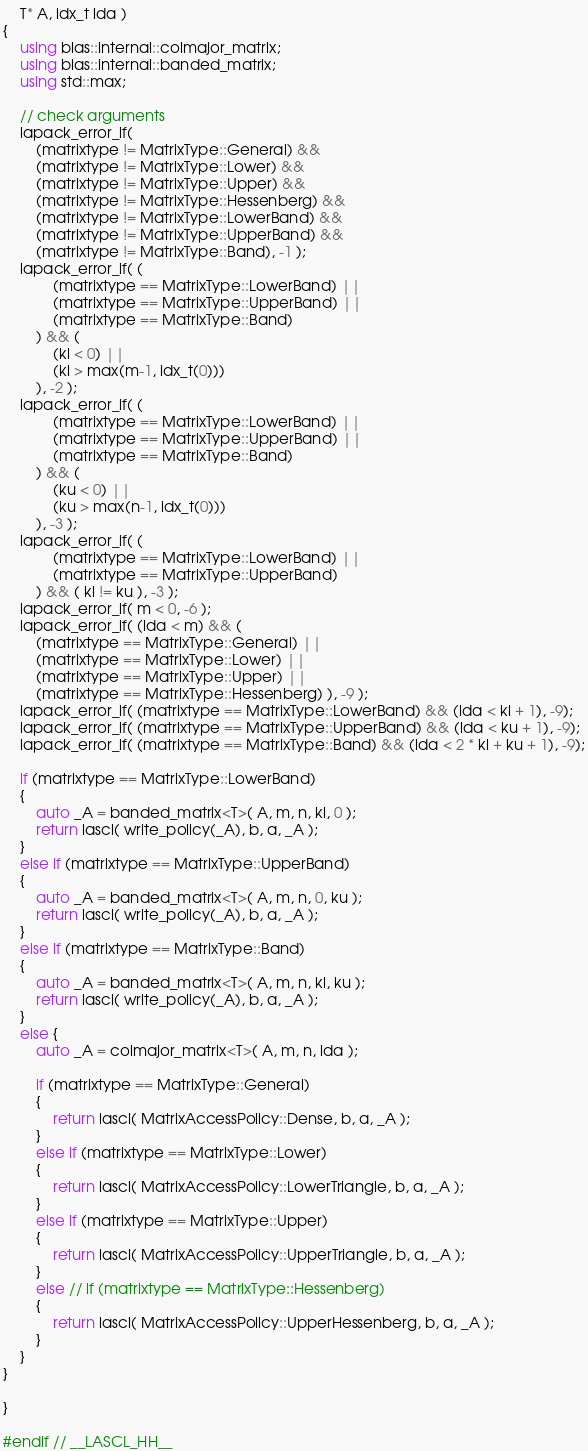<code> <loc_0><loc_0><loc_500><loc_500><_C++_>    T* A, idx_t lda )
{
    using blas::internal::colmajor_matrix;
    using blas::internal::banded_matrix;
    using std::max;
    
    // check arguments
    lapack_error_if(
        (matrixtype != MatrixType::General) && 
        (matrixtype != MatrixType::Lower) && 
        (matrixtype != MatrixType::Upper) && 
        (matrixtype != MatrixType::Hessenberg) && 
        (matrixtype != MatrixType::LowerBand) && 
        (matrixtype != MatrixType::UpperBand) && 
        (matrixtype != MatrixType::Band), -1 );
    lapack_error_if( (
            (matrixtype == MatrixType::LowerBand) ||
            (matrixtype == MatrixType::UpperBand) || 
            (matrixtype == MatrixType::Band)
        ) && (
            (kl < 0) ||
            (kl > max(m-1, idx_t(0)))
        ), -2 );
    lapack_error_if( (
            (matrixtype == MatrixType::LowerBand) ||
            (matrixtype == MatrixType::UpperBand) || 
            (matrixtype == MatrixType::Band)
        ) && (
            (ku < 0) ||
            (ku > max(n-1, idx_t(0)))
        ), -3 );
    lapack_error_if( (
            (matrixtype == MatrixType::LowerBand) ||
            (matrixtype == MatrixType::UpperBand)
        ) && ( kl != ku ), -3 );
    lapack_error_if( m < 0, -6 );
    lapack_error_if( (lda < m) && (
        (matrixtype == MatrixType::General) || 
        (matrixtype == MatrixType::Lower) ||
        (matrixtype == MatrixType::Upper) ||
        (matrixtype == MatrixType::Hessenberg) ), -9 );
    lapack_error_if( (matrixtype == MatrixType::LowerBand) && (lda < kl + 1), -9);
    lapack_error_if( (matrixtype == MatrixType::UpperBand) && (lda < ku + 1), -9);
    lapack_error_if( (matrixtype == MatrixType::Band) && (lda < 2 * kl + ku + 1), -9);

    if (matrixtype == MatrixType::LowerBand)
    {
        auto _A = banded_matrix<T>( A, m, n, kl, 0 );
        return lascl( write_policy(_A), b, a, _A );
    }
    else if (matrixtype == MatrixType::UpperBand)
    {
        auto _A = banded_matrix<T>( A, m, n, 0, ku );
        return lascl( write_policy(_A), b, a, _A );
    }
    else if (matrixtype == MatrixType::Band)
    {
        auto _A = banded_matrix<T>( A, m, n, kl, ku );
        return lascl( write_policy(_A), b, a, _A );
    }
    else {
        auto _A = colmajor_matrix<T>( A, m, n, lda );
        
        if (matrixtype == MatrixType::General)
        {
            return lascl( MatrixAccessPolicy::Dense, b, a, _A );
        }
        else if (matrixtype == MatrixType::Lower)
        {
            return lascl( MatrixAccessPolicy::LowerTriangle, b, a, _A );
        }
        else if (matrixtype == MatrixType::Upper)
        {
            return lascl( MatrixAccessPolicy::UpperTriangle, b, a, _A );
        }
        else // if (matrixtype == MatrixType::Hessenberg)
        {
            return lascl( MatrixAccessPolicy::UpperHessenberg, b, a, _A );
        }
    }
}

}

#endif // __LASCL_HH__
</code> 